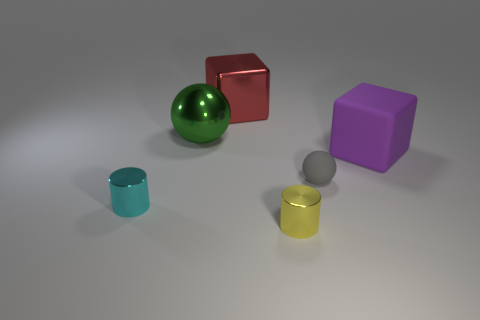There is a small gray object that is the same material as the large purple cube; what is its shape?
Make the answer very short. Sphere. What is the color of the ball that is on the left side of the small thing that is on the right side of the yellow cylinder?
Provide a succinct answer. Green. Do the big metallic sphere and the small rubber object have the same color?
Your answer should be very brief. No. What material is the small cylinder that is to the right of the sphere that is on the left side of the gray matte sphere?
Keep it short and to the point. Metal. What material is the other thing that is the same shape as the gray thing?
Your response must be concise. Metal. There is a matte thing on the left side of the block in front of the red metal cube; are there any small spheres that are to the right of it?
Offer a very short reply. No. How many other objects are there of the same color as the matte cube?
Offer a terse response. 0. How many big things are to the left of the large shiny cube and right of the yellow cylinder?
Offer a terse response. 0. What shape is the tiny rubber thing?
Make the answer very short. Sphere. How many other objects are there of the same material as the large purple thing?
Provide a succinct answer. 1. 